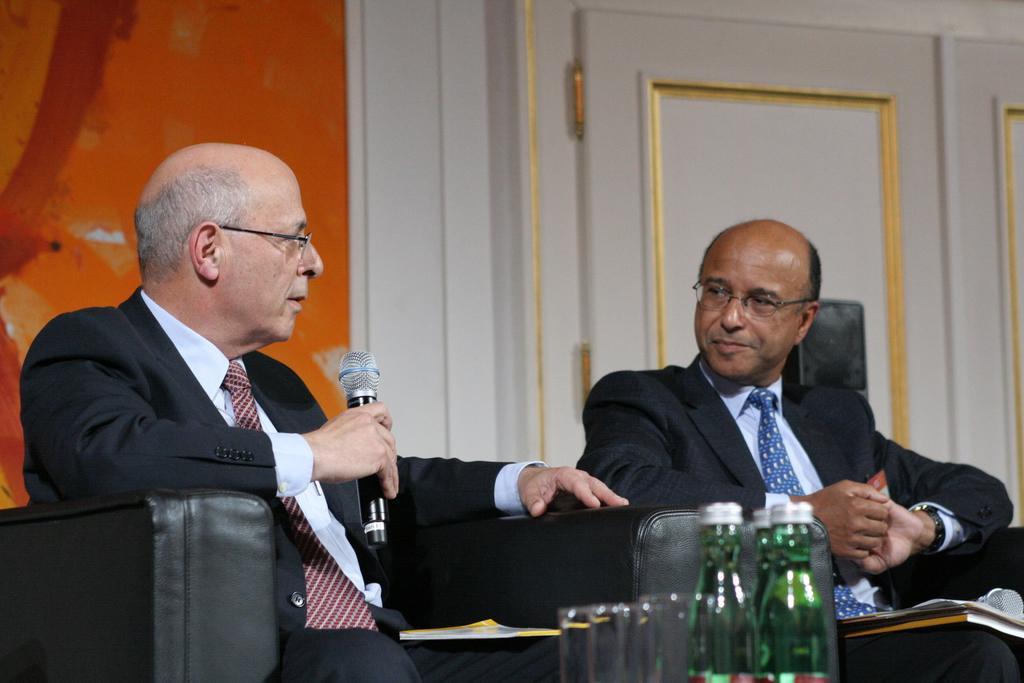Please provide a concise description of this image. As we can see in the image there are two persons sitting on sofa and the person sitting on the left side is holding mike in his hand. In the front there are two bottles. 